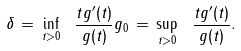<formula> <loc_0><loc_0><loc_500><loc_500>\delta \, = \, \inf _ { t > 0 } \ \frac { t g ^ { \prime } ( t ) } { g ( t ) } g _ { 0 } \, = \, \sup _ { t > 0 } \ \frac { t g ^ { \prime } ( t ) } { g ( t ) } .</formula> 